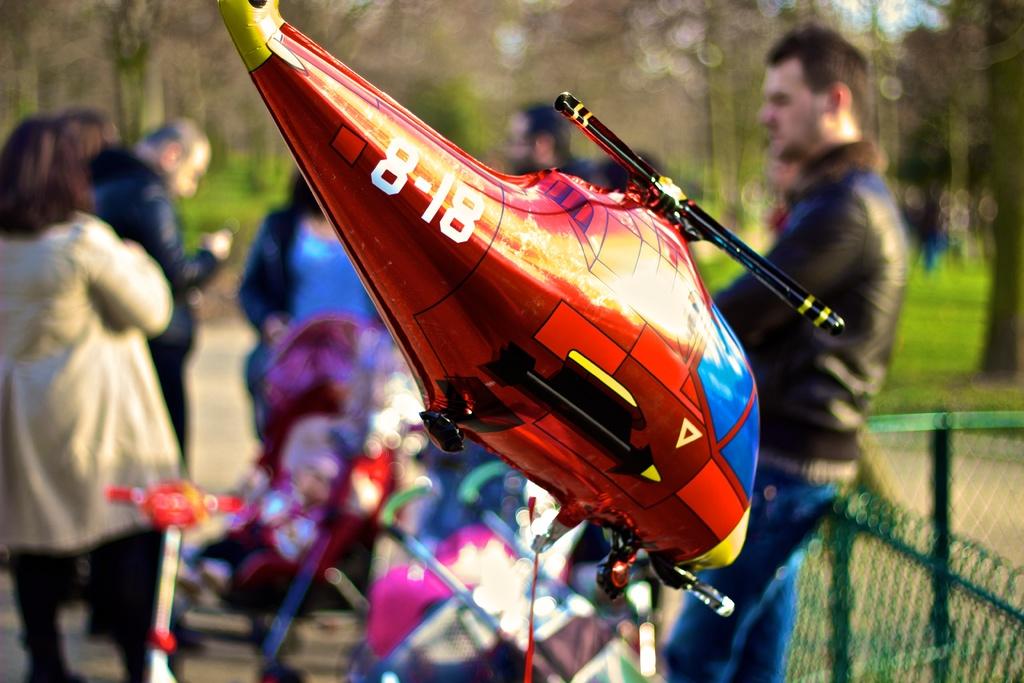What vehicle number is featured?
Make the answer very short. 8-18. What are the three numbers on the helicopter balloon?
Ensure brevity in your answer.  8-18. 